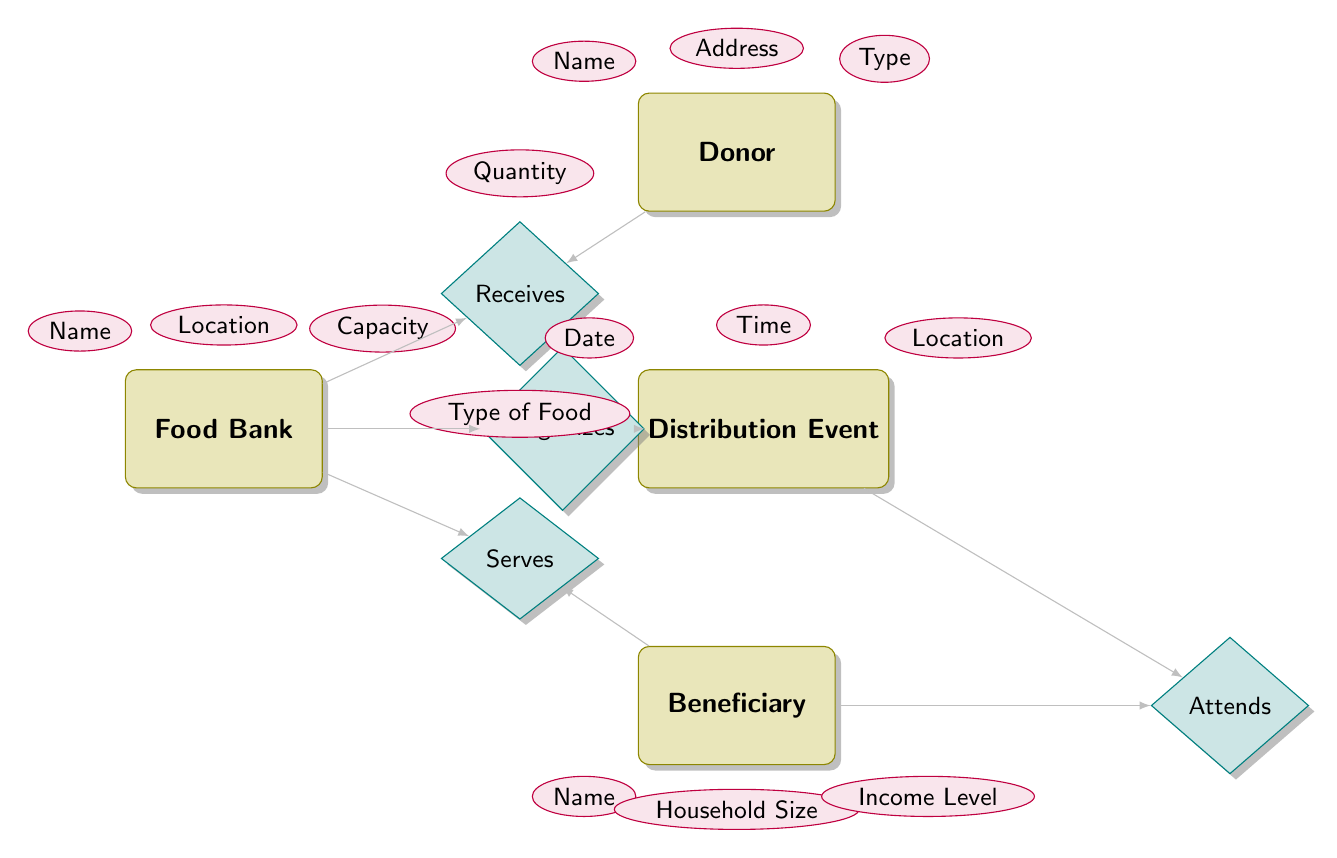What is the name of one entity in the diagram? The diagram includes multiple entities, one of which is clearly labeled as "Food Bank."
Answer: Food Bank Which entity has the attribute "Location"? The attribute "Location" is associated with the entity "Food Bank," which has details regarding its site.
Answer: Food Bank How many entities are represented in the diagram? By counting, we can see there are four distinct entities: Food Bank, Donor, Beneficiary, and Distribution Event.
Answer: Four What is the relationship between "Food Bank" and "Donor"? The diagram shows an association where "Food Bank" has a relationship labeled "Receives" with "Donor," indicating the action of receiving contributions.
Answer: Receives What type of information can a "Beneficiary" receive from a "Distribution Event"? The "Attends" relationship indicates that "Beneficiary" can participate in "Distribution Event," thus receiving food or assistance during these occurrences.
Answer: Assistance Which entity serves beneficiaries in the diagram? The "Serves" relationship identifies that "Food Bank" is the entity that serves the "Beneficiary," connecting them in the distribution of food.
Answer: Food Bank What attributes describe a "Donor"? The "Donor" entity includes attributes such as "Name," "Address," and "Type," providing detailed information about individuals or organizations donating food.
Answer: Name, Address, Type How is the "Distribution Event" connected to the "Food Bank"? The "Organizes" relationship illustrates that the "Food Bank" is responsible for planning and executing the "Distribution Event."
Answer: Organizes Which entity type characterizes the participants at an event? The relationship "Attends" links "Beneficiaries" as the participants who attend various "Distribution Events" conducted by the food bank.
Answer: Beneficiary 